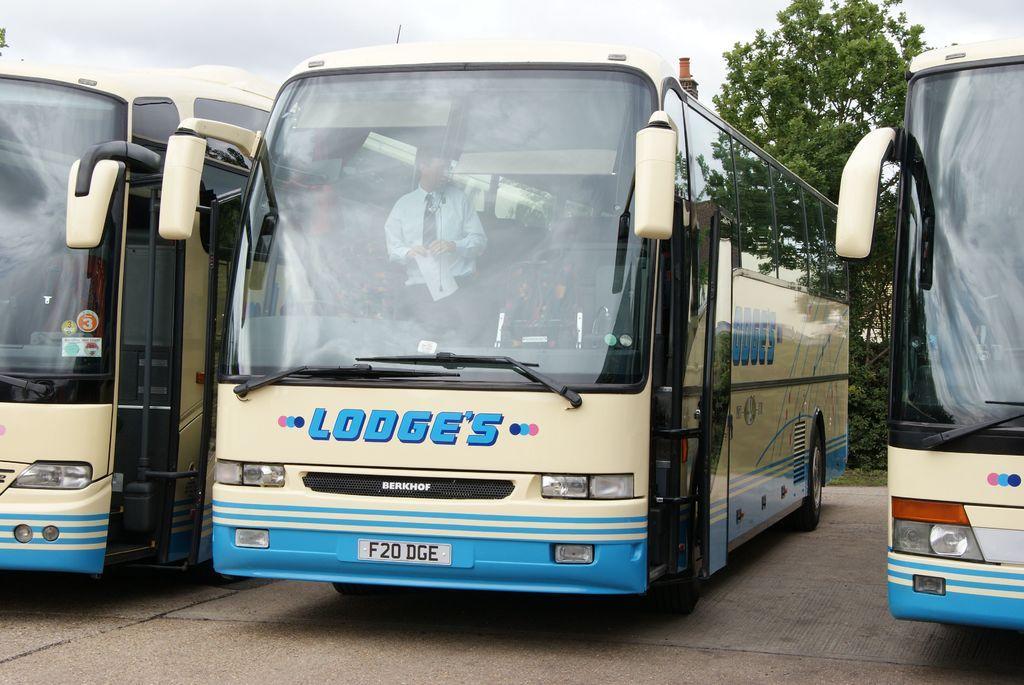How would you summarize this image in a sentence or two? In this picture we can see buses on the ground with a man standing inside it and holding a paper with his hands and in the background we can see trees, sky with clouds. 